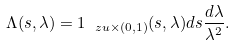<formula> <loc_0><loc_0><loc_500><loc_500>\Lambda ( s , \lambda ) = { 1 } _ { \ z u \times ( 0 , 1 ) } ( s , \lambda ) d s \frac { d \lambda } { \lambda ^ { 2 } } .</formula> 